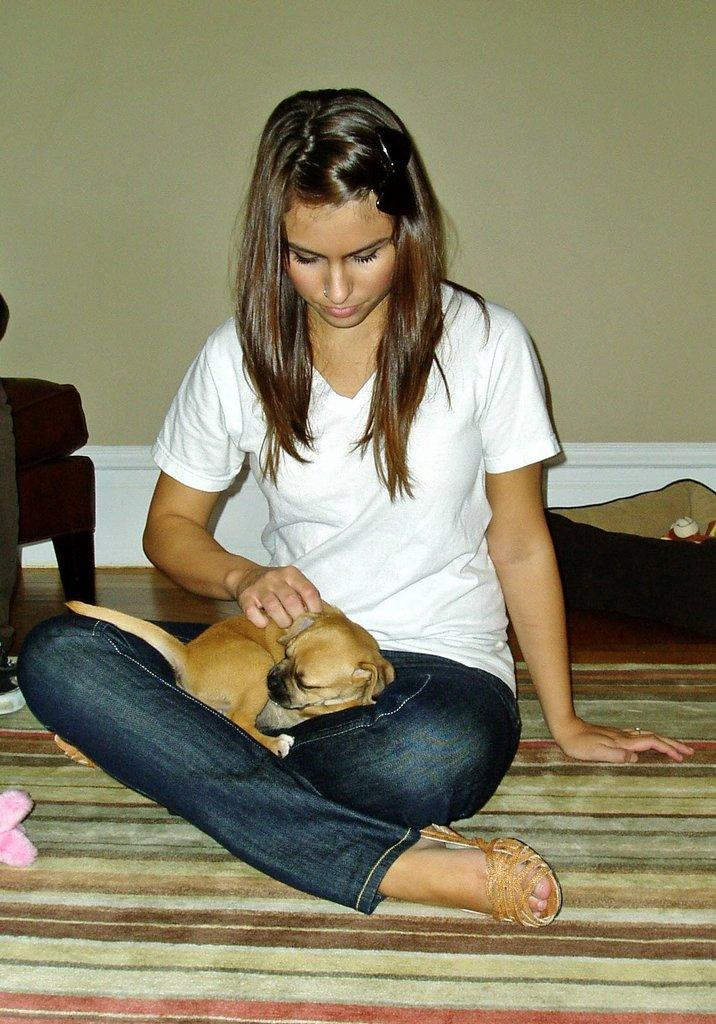Who is present in the image? There is a woman in the image. What is the woman doing in the image? The woman is sitting on the floor. Is there any other living being in the image? Yes, there is a dog in the image. How is the dog positioned in relation to the woman? The dog is sitting on the woman's lap. What can be seen in the background of the image? There is a wall in the background of the image. What type of knot is the woman tying in the image? There is no knot present in the image. What kind of flower is the dog holding in its mouth in the image? There is no flower present in the image, and the dog is not holding anything in its mouth. 